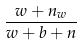Convert formula to latex. <formula><loc_0><loc_0><loc_500><loc_500>\frac { w + n _ { w } } { w + b + n }</formula> 